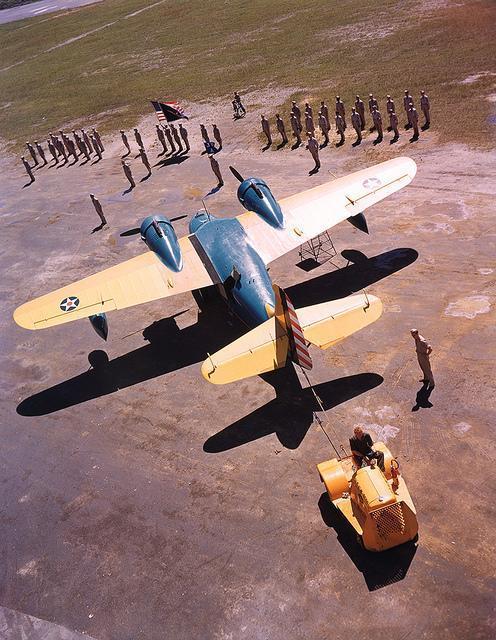How many airplanes can be seen?
Give a very brief answer. 1. 